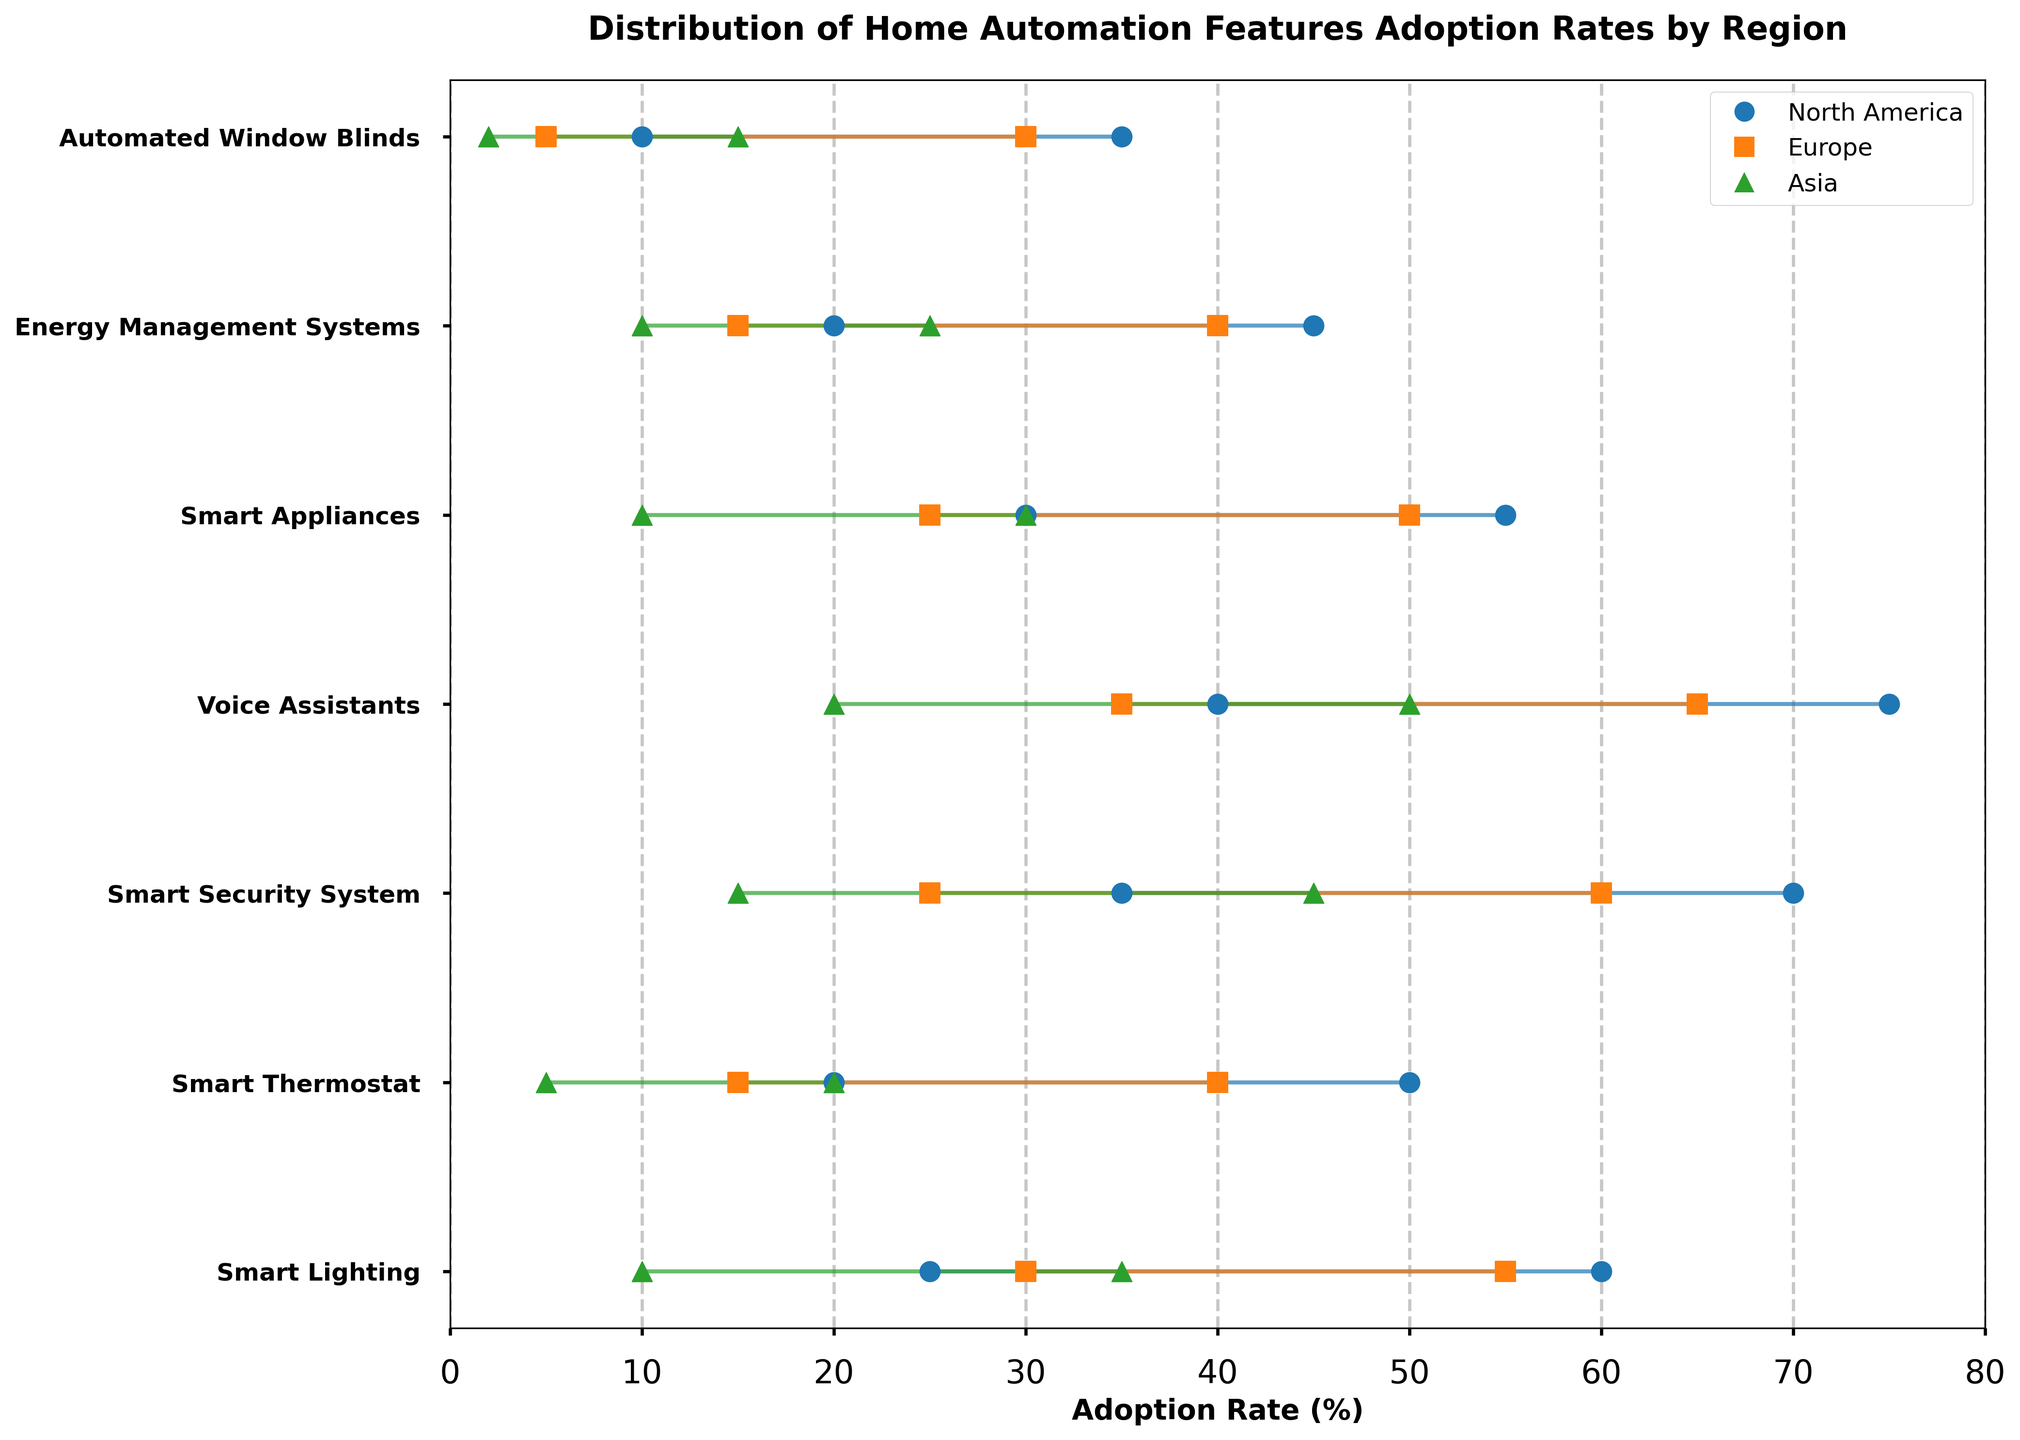What is the title of the plot? The title of the plot is found at the top, which provides an overview of the visualized data. The title reads "Distribution of Home Automation Features Adoption Rates by Region."
Answer: Distribution of Home Automation Features Adoption Rates by Region Which region has the highest maximum adoption rate for Voice Assistants? Look at the lines and markers representing Voice Assistants. The maximum adoption rates are represented by the highest point on the x-axis for each region. North America has the highest maximum adoption rate for Voice Assistants at 75%.
Answer: North America What is the range of adoption rates for Smart Security Systems in Europe? Find the Smart Security Systems row on the y-axis, then locate the line and markers for Europe (represented in orange). The endpoints of the line give the minimum and maximum adoption rates: 25% to 60%. The range is calculated as 60% - 25%.
Answer: 35% Which home automation feature has the smallest adoption range in Asia? Compare the lengths of the horizontal lines for each home automation feature in the region of Asia (green markers). Automated Window Blinds in Asia range from 2% to 15%, which is the smallest range compared to other features.
Answer: Automated Window Blinds How does the adoption range of Smart Lighting in Europe compare to North America? For Smart Lighting, compare the span of the horizontal lines representing Europe and North America. In Europe, the range is from 30% to 55% (25%), while in North America, it is from 25% to 60% (35%). Europe has a smaller adoption range.
Answer: Europe has a smaller range Which region has the highest minimum adoption rate for Energy Management Systems? Look at the lines for Energy Management Systems on the y-axis, focusing on the positions of the minimum points. North America, represented in blue, has the highest minimum rate, which is 20%.
Answer: North America What is the average maximum adoption rate for Smart Thermostats in all regions? First, identify the maximum adoption rates for Smart Thermostats across all regions: North America (50%), Europe (40%), and Asia (20%). Sum these values: 50 + 40 + 20 = 110. Then, divide by the number of regions: 110 / 3 ≈ 36.67.
Answer: ~36.67% Which home automation feature in North America has the closest maximum adoption rate to 60%? Look for the North American (blue) maximum markers close to 60%. Both Smart Lighting and Smart Security System have a maximum adoption rate of 60%.
Answer: Smart Lighting and Smart Security System What is the difference in the maximum adoption rates of Smart Appliances between North America and Asia? Identify the maximum adoption rates for Smart Appliances. For North America, it is 55%, and for Asia, it is 30%. The difference is calculated as 55% - 30% = 25%.
Answer: 25% Which feature has the largest adoption range in all regions? Observe the lengths of the lines for each feature across regions and find the longest. Voice Assistants in North America have the largest adoption range, going from 40% to 75%, a span of 35%.
Answer: Voice Assistants in North America 